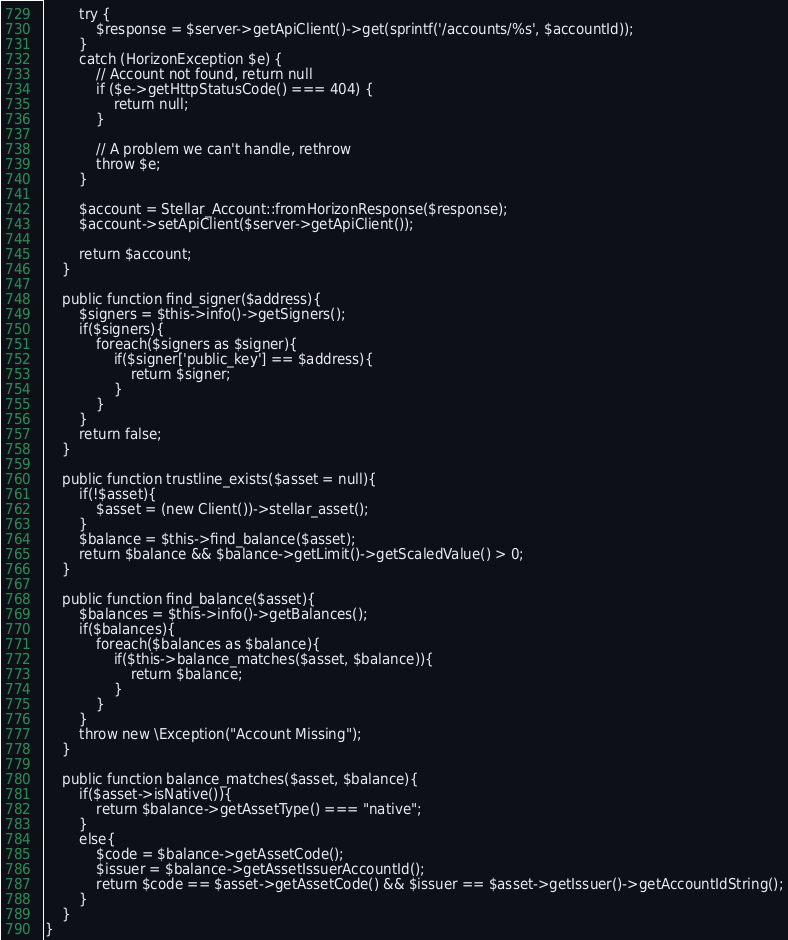Convert code to text. <code><loc_0><loc_0><loc_500><loc_500><_PHP_>        try {
            $response = $server->getApiClient()->get(sprintf('/accounts/%s', $accountId));
        }
        catch (HorizonException $e) {
            // Account not found, return null
            if ($e->getHttpStatusCode() === 404) {
                return null;
            }

            // A problem we can't handle, rethrow
            throw $e;
        }

        $account = Stellar_Account::fromHorizonResponse($response);
        $account->setApiClient($server->getApiClient());

        return $account;
    }

    public function find_signer($address){
        $signers = $this->info()->getSigners();
        if($signers){
            foreach($signers as $signer){
                if($signer['public_key'] == $address){
                    return $signer;
                }
            }
        }
        return false;
    }

    public function trustline_exists($asset = null){
        if(!$asset){
            $asset = (new Client())->stellar_asset();
        }
        $balance = $this->find_balance($asset);
        return $balance && $balance->getLimit()->getScaledValue() > 0;
    }

    public function find_balance($asset){
        $balances = $this->info()->getBalances();
        if($balances){
            foreach($balances as $balance){
                if($this->balance_matches($asset, $balance)){
                    return $balance;
                }
            }
        }
        throw new \Exception("Account Missing");
    }

    public function balance_matches($asset, $balance){
        if($asset->isNative()){
            return $balance->getAssetType() === "native";
        }
        else{
            $code = $balance->getAssetCode();
            $issuer = $balance->getAssetIssuerAccountId();
            return $code == $asset->getAssetCode() && $issuer == $asset->getIssuer()->getAccountIdString();
        }
    }
}
</code> 